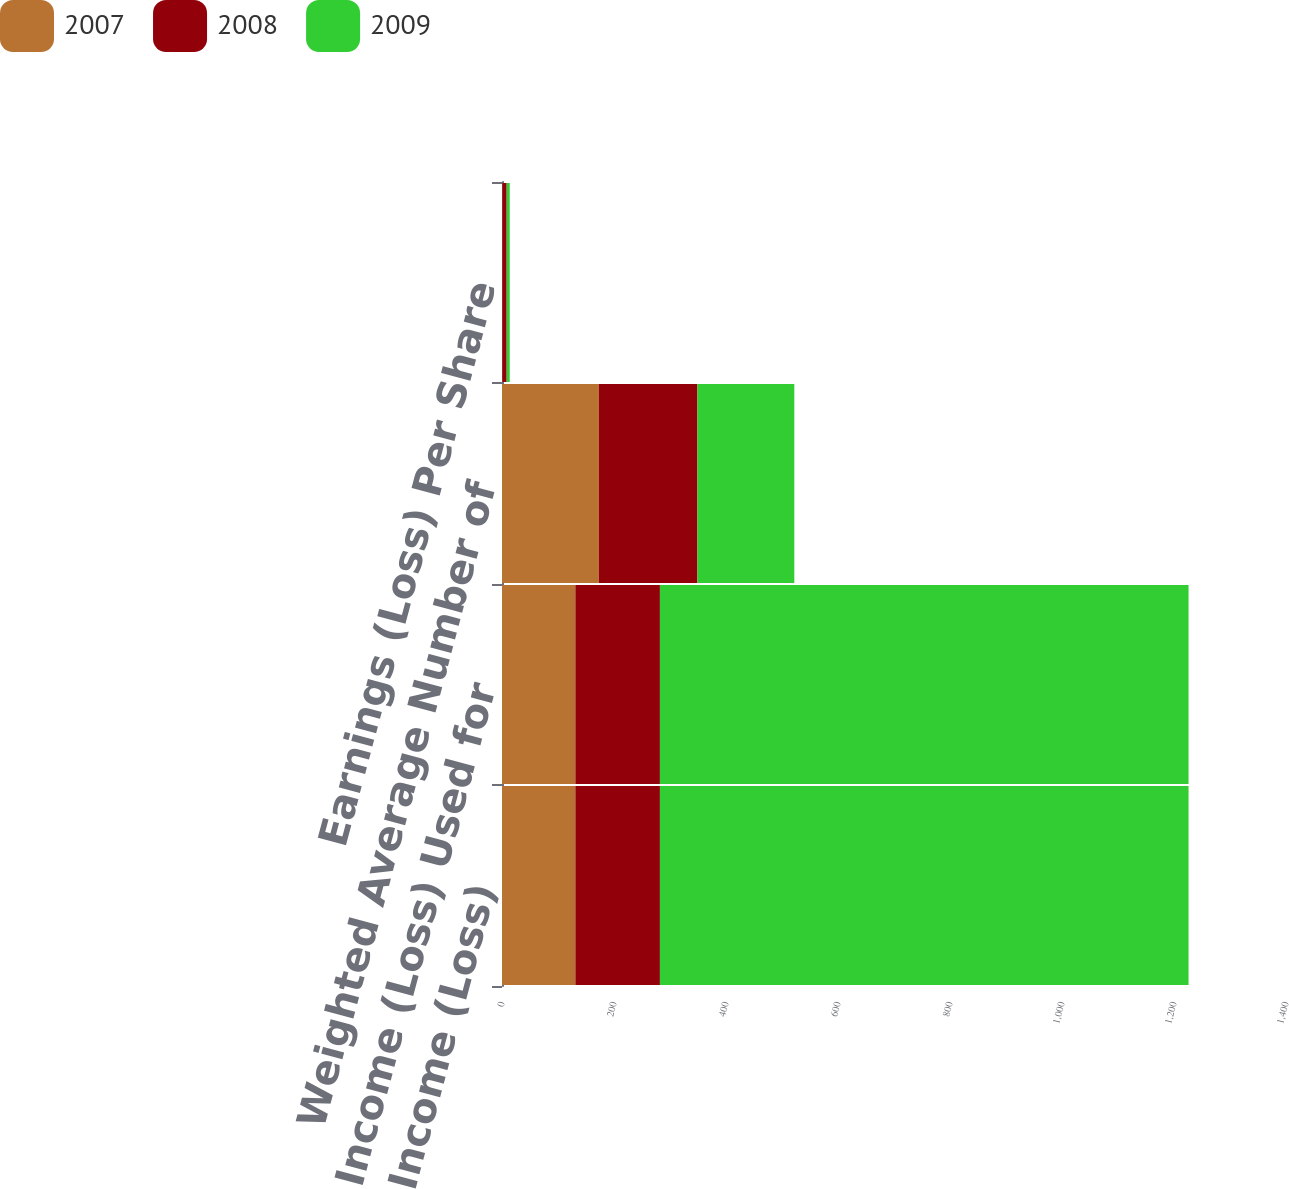Convert chart to OTSL. <chart><loc_0><loc_0><loc_500><loc_500><stacked_bar_chart><ecel><fcel>Net Income (Loss)<fcel>Net Income (Loss) Used for<fcel>Weighted Average Number of<fcel>Earnings (Loss) Per Share<nl><fcel>2007<fcel>131<fcel>131<fcel>173<fcel>0.75<nl><fcel>2008<fcel>151<fcel>151<fcel>176<fcel>7.58<nl><fcel>2009<fcel>944<fcel>944<fcel>173<fcel>5.45<nl></chart> 